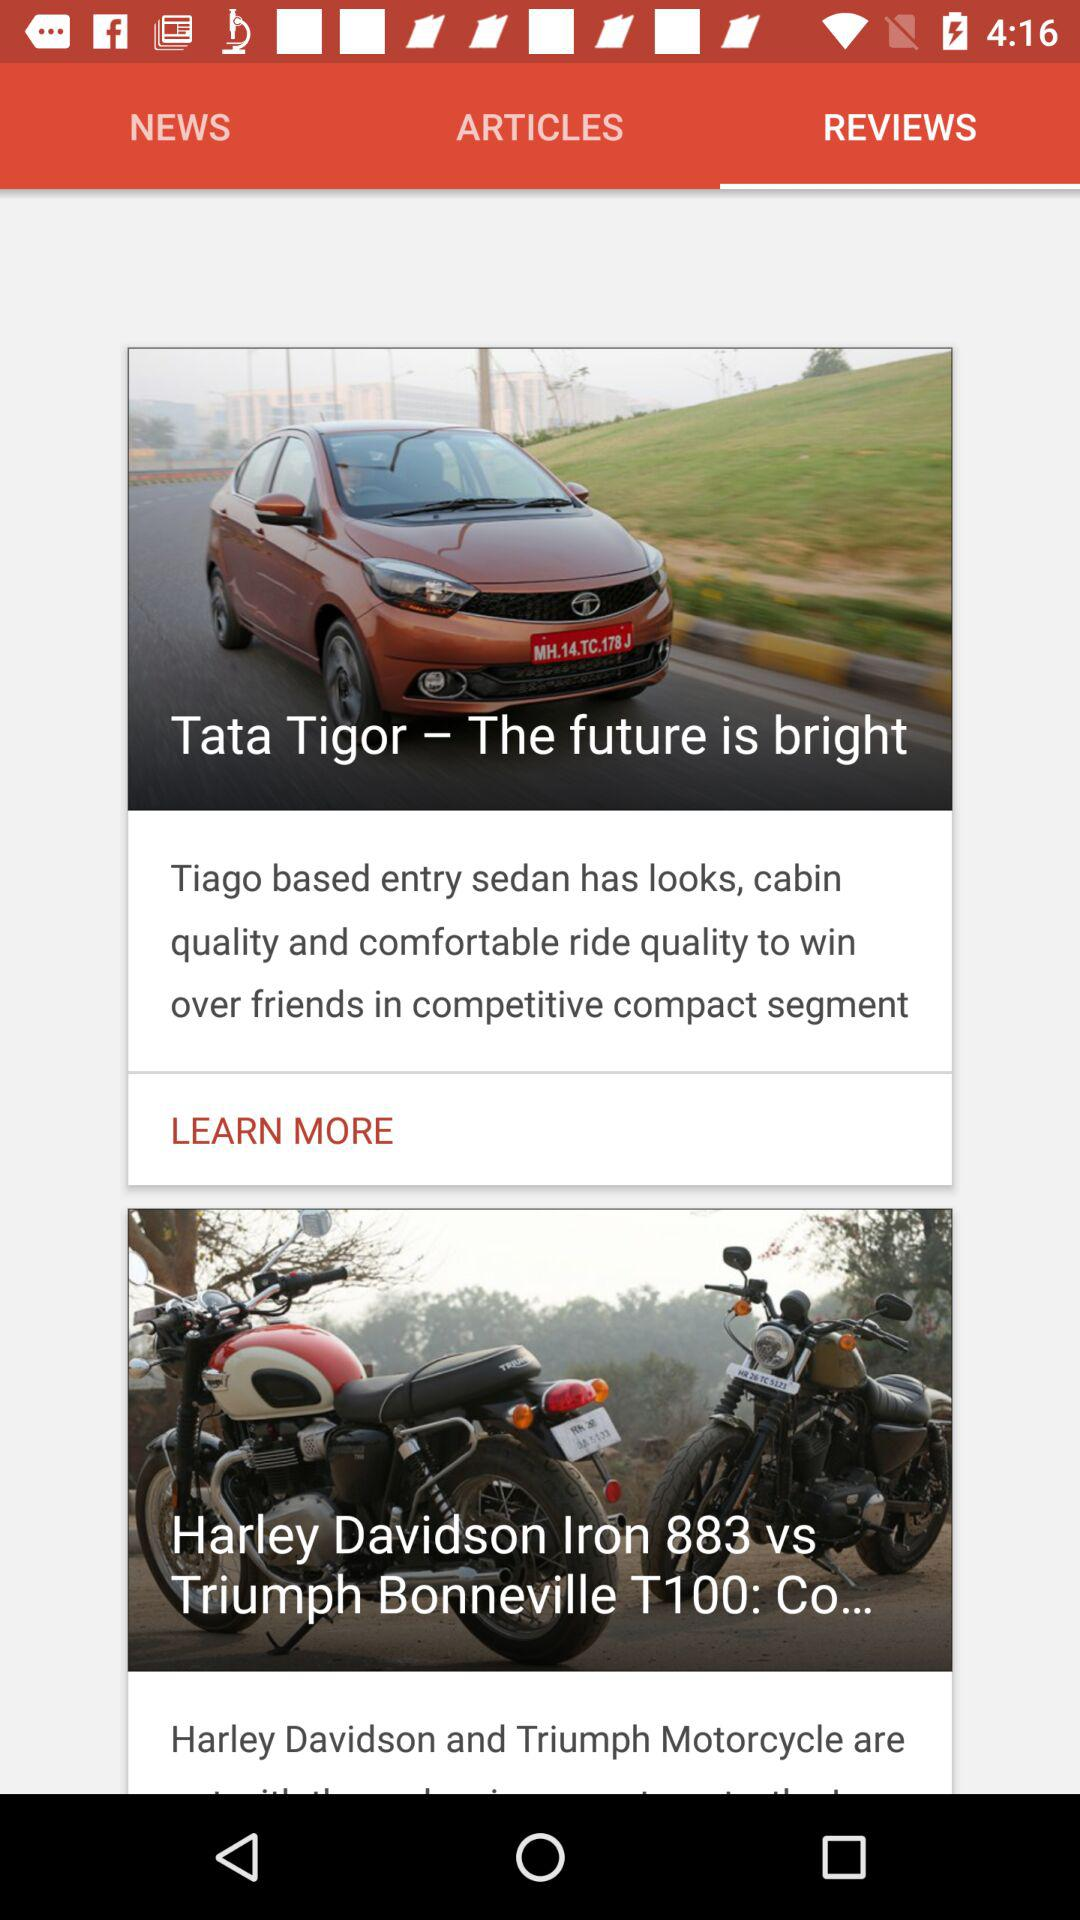Which tab is selected? The selected tab is "REVIEWS". 